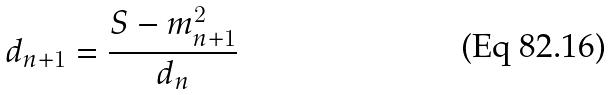<formula> <loc_0><loc_0><loc_500><loc_500>d _ { n + 1 } = \frac { S - m _ { n + 1 } ^ { 2 } } { d _ { n } }</formula> 